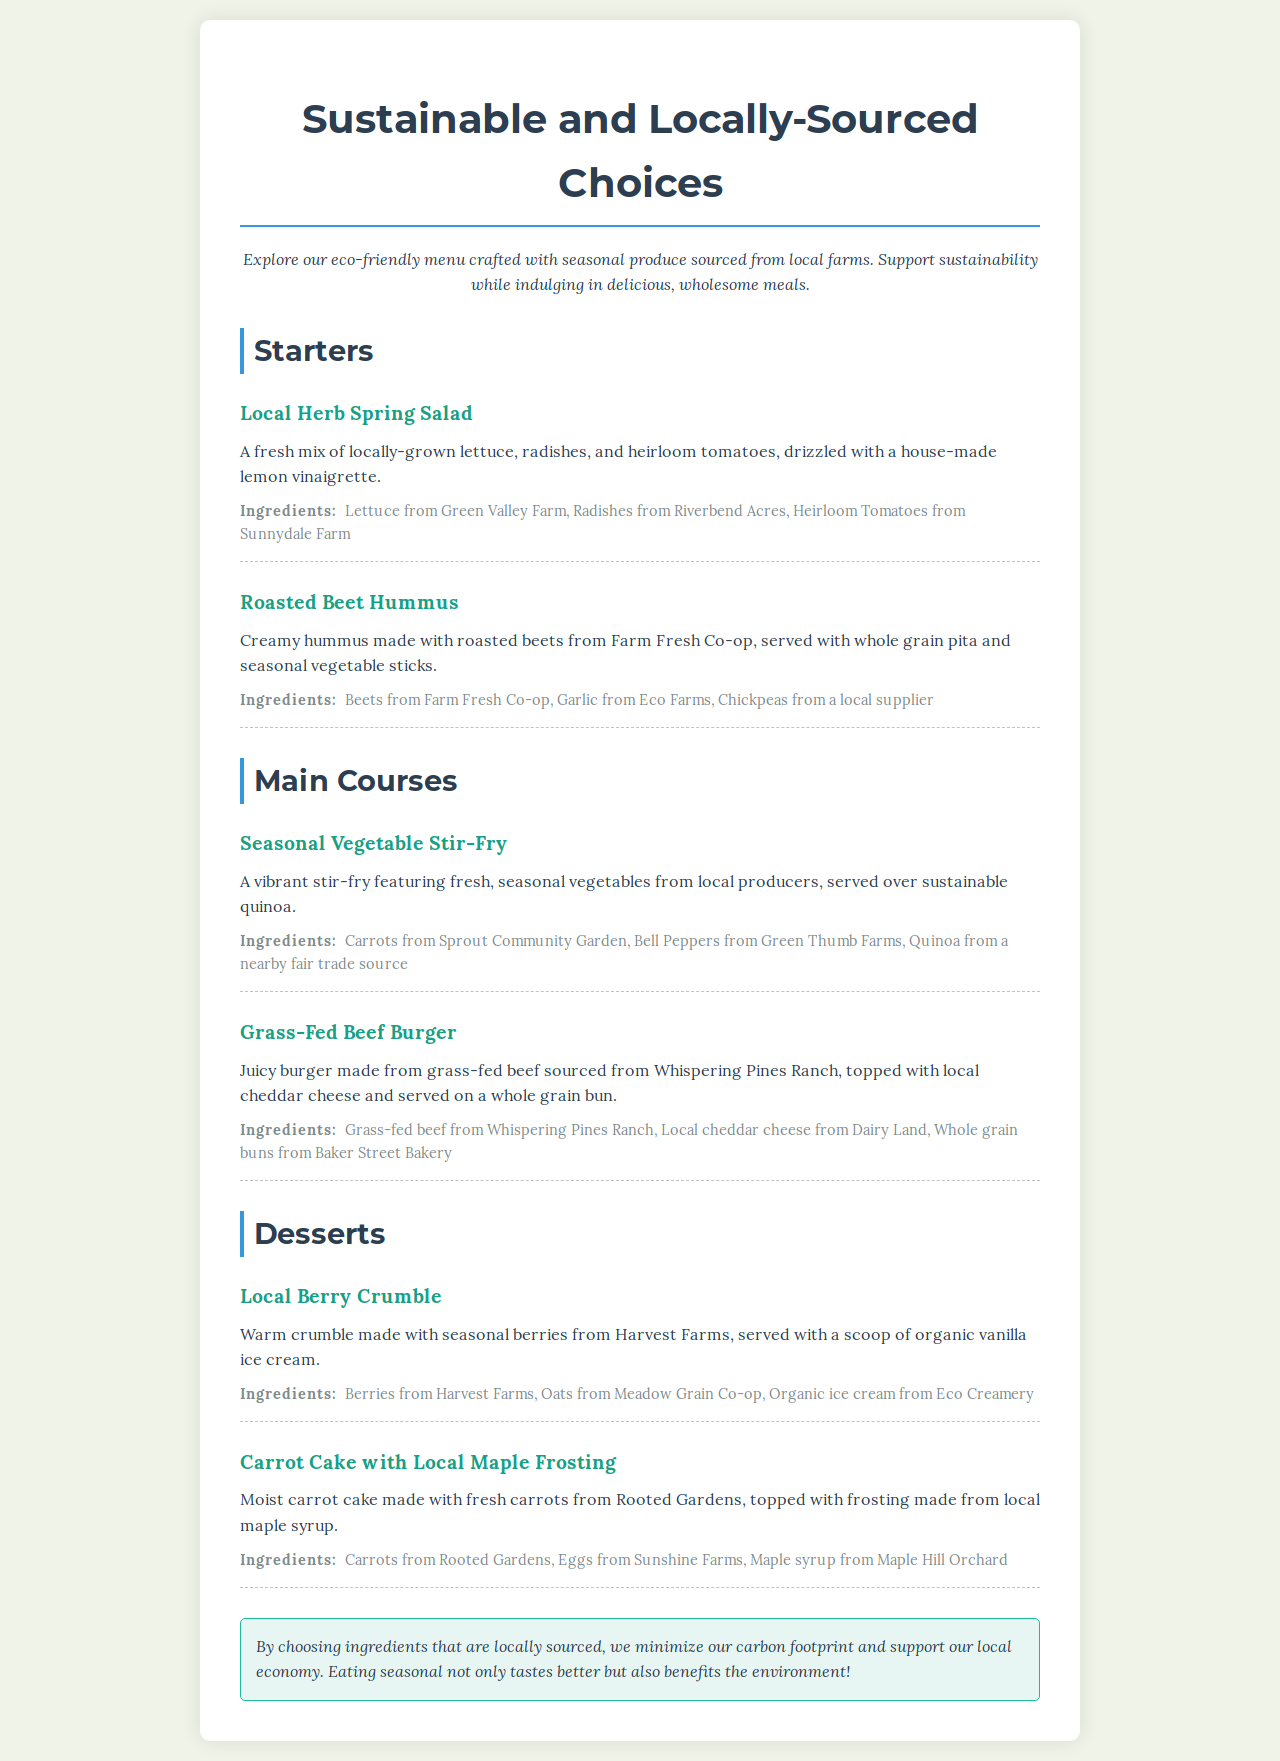What is the title of the menu? The title of the menu is prominently displayed at the top.
Answer: Sustainable and Locally-Sourced Choices What type of dressing is used in the Local Herb Spring Salad? The dressing for the salad is specified in the dish description.
Answer: Lemon vinaigrette Which farm supplies the heirloom tomatoes? The specific farm for the heirloom tomatoes is mentioned in the ingredients section.
Answer: Sunnydale Farm What is the main protein in the Grass-Fed Beef Burger? The protein type is indicated in the name of the dish and its description.
Answer: Grass-fed beef Which dessert features seasonal berries? This is identified in the dessert section by the dish name.
Answer: Local Berry Crumble How does the menu emphasize sustainability? The sustainability message is articulated in a specific section at the end of the menu.
Answer: Minimize carbon footprint What is the primary ingredient in the Roasted Beet Hummus? The key ingredient is specified in the dish name and description.
Answer: Beets Which ingredient used in the Carrot Cake comes from Sunshine Farms? This ingredient is detailed in the dish's ingredient list.
Answer: Eggs 